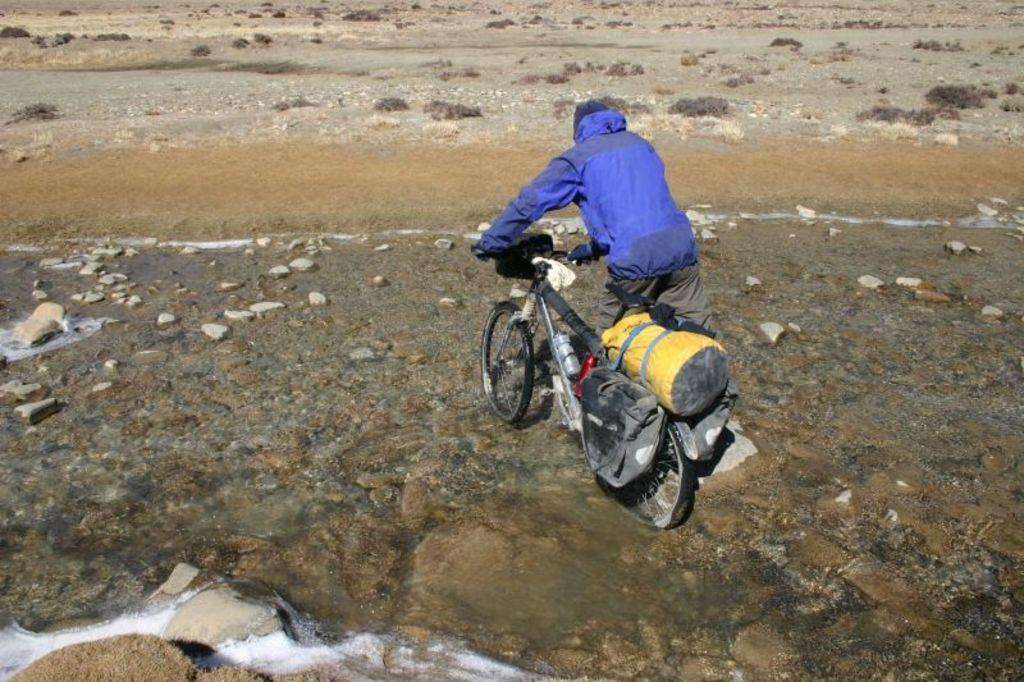Who is the main subject in the image? There is a man in the image. What is the man doing in the image? The man is walking in the water. What is the man holding in the image? The man is holding a bicycle. What type of natural elements can be seen in the image? Stones and shrubs are present in the image. What type of shop can be seen in the image? There is no shop present in the image. Who is the mother in the image? There is no mother present in the image. 